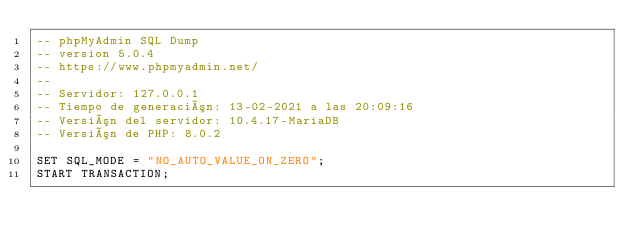<code> <loc_0><loc_0><loc_500><loc_500><_SQL_>-- phpMyAdmin SQL Dump
-- version 5.0.4
-- https://www.phpmyadmin.net/
--
-- Servidor: 127.0.0.1
-- Tiempo de generación: 13-02-2021 a las 20:09:16
-- Versión del servidor: 10.4.17-MariaDB
-- Versión de PHP: 8.0.2

SET SQL_MODE = "NO_AUTO_VALUE_ON_ZERO";
START TRANSACTION;</code> 